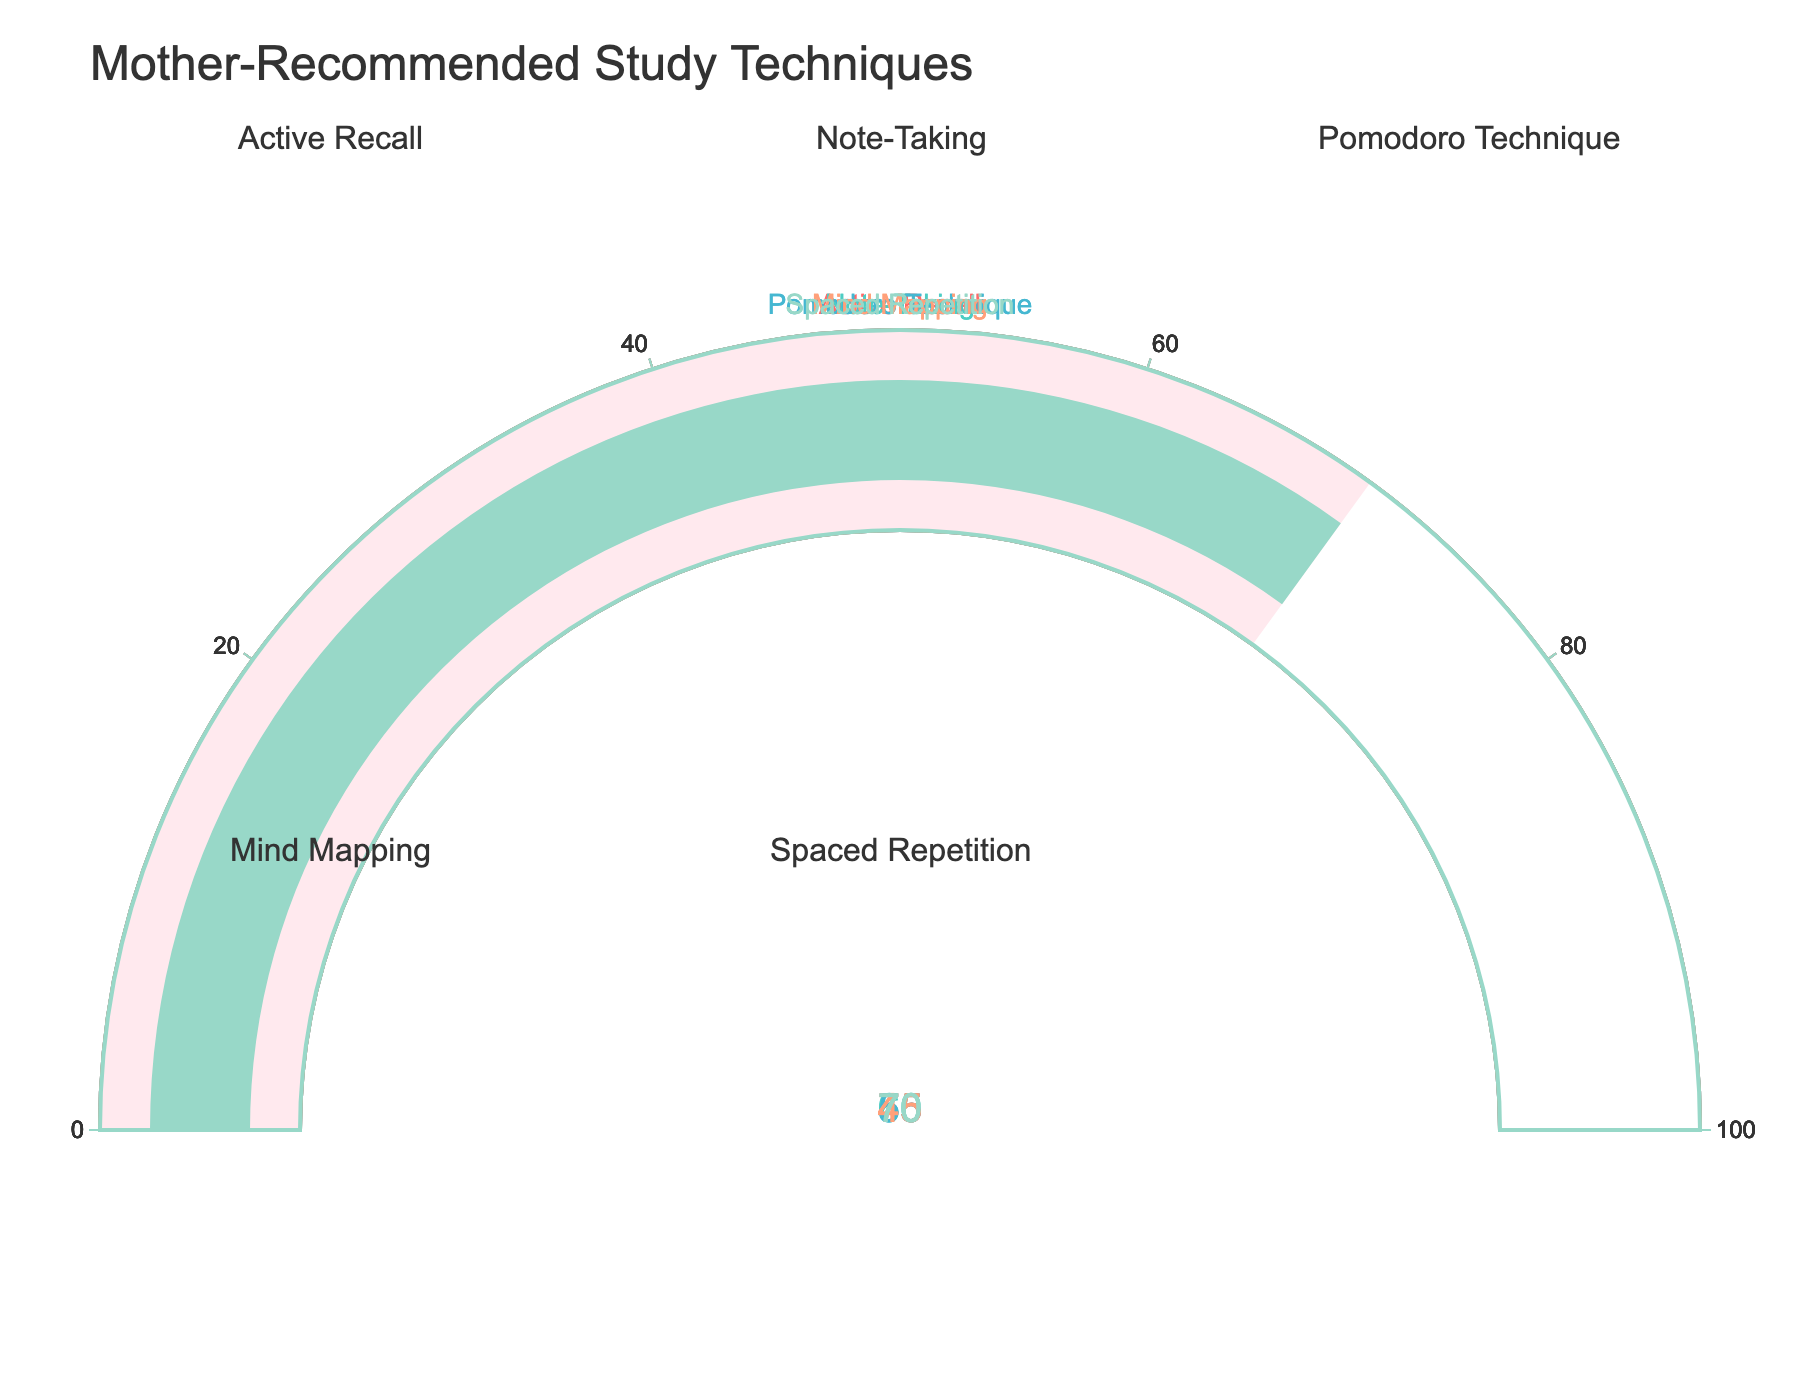Which study technique has the highest percentage of study time dedicated to it? By looking at the gauge chart, we see that "Active Recall" has the needle pointing at 75%, which is the highest percentage among all the techniques.
Answer: Active Recall Which two study techniques have the closest percentages of study time dedicated to them? Comparing the percentages, we see that "Pomodoro Technique" is at 55% and "Mind Mapping" is at 45%, making the difference 10%, the smallest among the pairings.
Answer: Pomodoro Technique and Mind Mapping What is the average percentage of study time dedicated to all the techniques? Adding the percentages: 75 + 60 + 55 + 45 + 70 = 305. Then, dividing by the number of techniques (5), we get 305 / 5 = 61.
Answer: 61 Which study technique occupies the middle position in terms of percentage of study time when the values are ordered? When ordered, the percentages are 45, 55, 60, 70, 75. The middle value is 60, corresponding to "Note-Taking".
Answer: Note-Taking What is the total percentage of study time dedicated to 'Active Recall' and 'Spaced Repetition' combined? Adding the percentages of "Active Recall" (75%) and "Spaced Repetition" (70%) gives 75 + 70 = 145.
Answer: 145 Which study technique has the lowest percentage of study time dedicated to it? By observing the lowest value on the gauge chart, "Mind Mapping" is at 45%, which is the smallest percentage.
Answer: Mind Mapping What is the percentage difference between 'Note-Taking' and 'Pomodoro Technique'? Subtract the percentage of "Pomodoro Technique" (55%) from "Note-Taking" (60%): 60 - 55 = 5.
Answer: 5 How many techniques have a percentage of study time of 60% or higher? Looking at the values: "Active Recall" (75%), "Note-Taking" (60%), and "Spaced Repetition" (70%) are 60% or higher. That's 3 techniques.
Answer: 3 